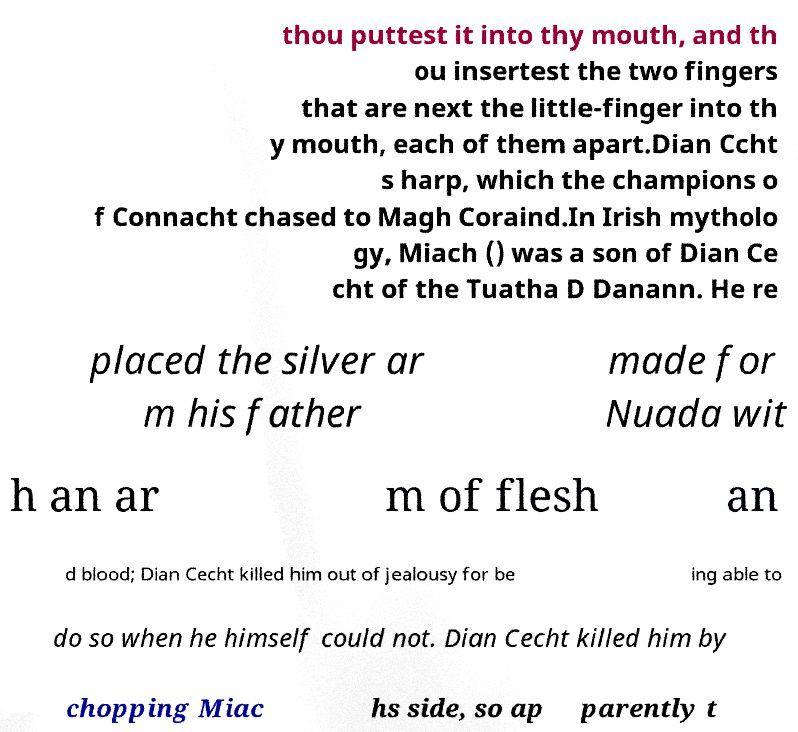Could you assist in decoding the text presented in this image and type it out clearly? thou puttest it into thy mouth, and th ou insertest the two fingers that are next the little-finger into th y mouth, each of them apart.Dian Ccht s harp, which the champions o f Connacht chased to Magh Coraind.In Irish mytholo gy, Miach () was a son of Dian Ce cht of the Tuatha D Danann. He re placed the silver ar m his father made for Nuada wit h an ar m of flesh an d blood; Dian Cecht killed him out of jealousy for be ing able to do so when he himself could not. Dian Cecht killed him by chopping Miac hs side, so ap parently t 